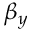Convert formula to latex. <formula><loc_0><loc_0><loc_500><loc_500>\beta _ { y }</formula> 